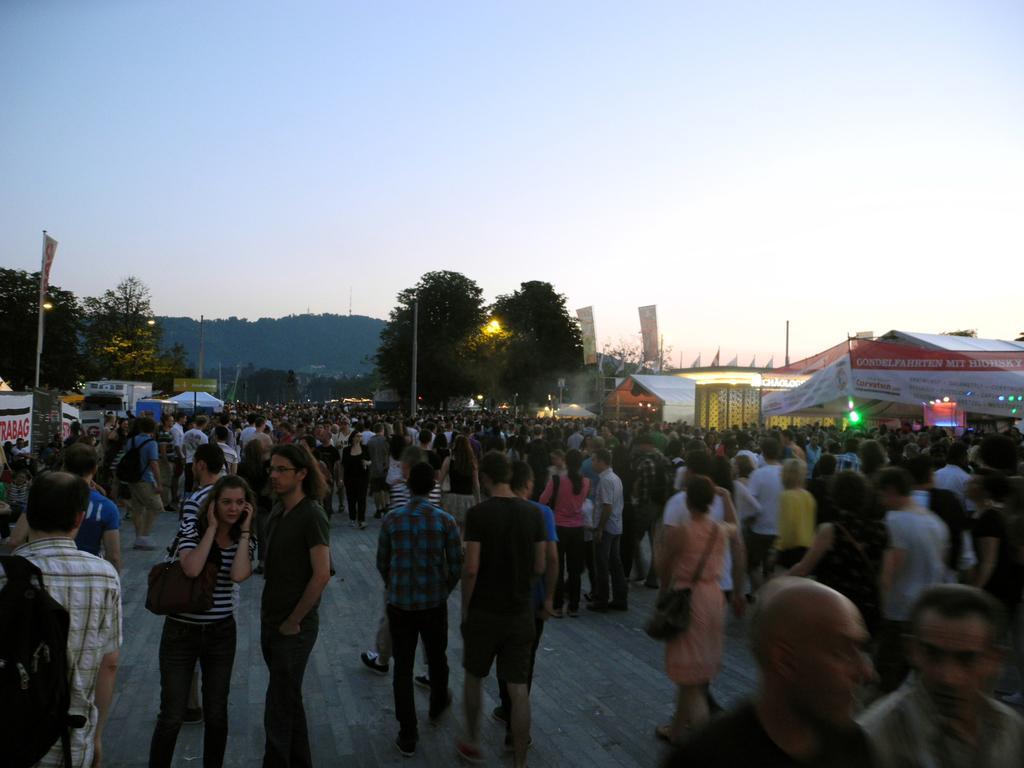Can you describe this image briefly? In this image there are a few people standing and walking on the road. On the right and left side of the image there are few stalls, banners and canopies. In the background there are trees, mountains and the sky. 